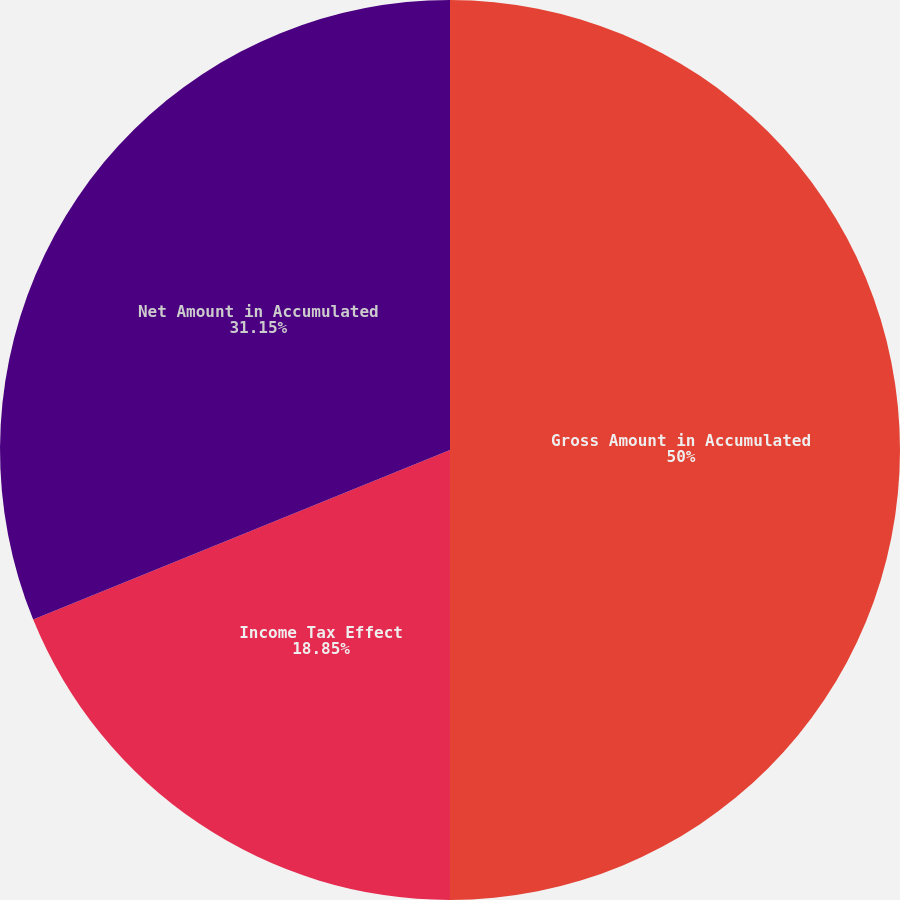Convert chart. <chart><loc_0><loc_0><loc_500><loc_500><pie_chart><fcel>Gross Amount in Accumulated<fcel>Income Tax Effect<fcel>Net Amount in Accumulated<nl><fcel>50.0%<fcel>18.85%<fcel>31.15%<nl></chart> 